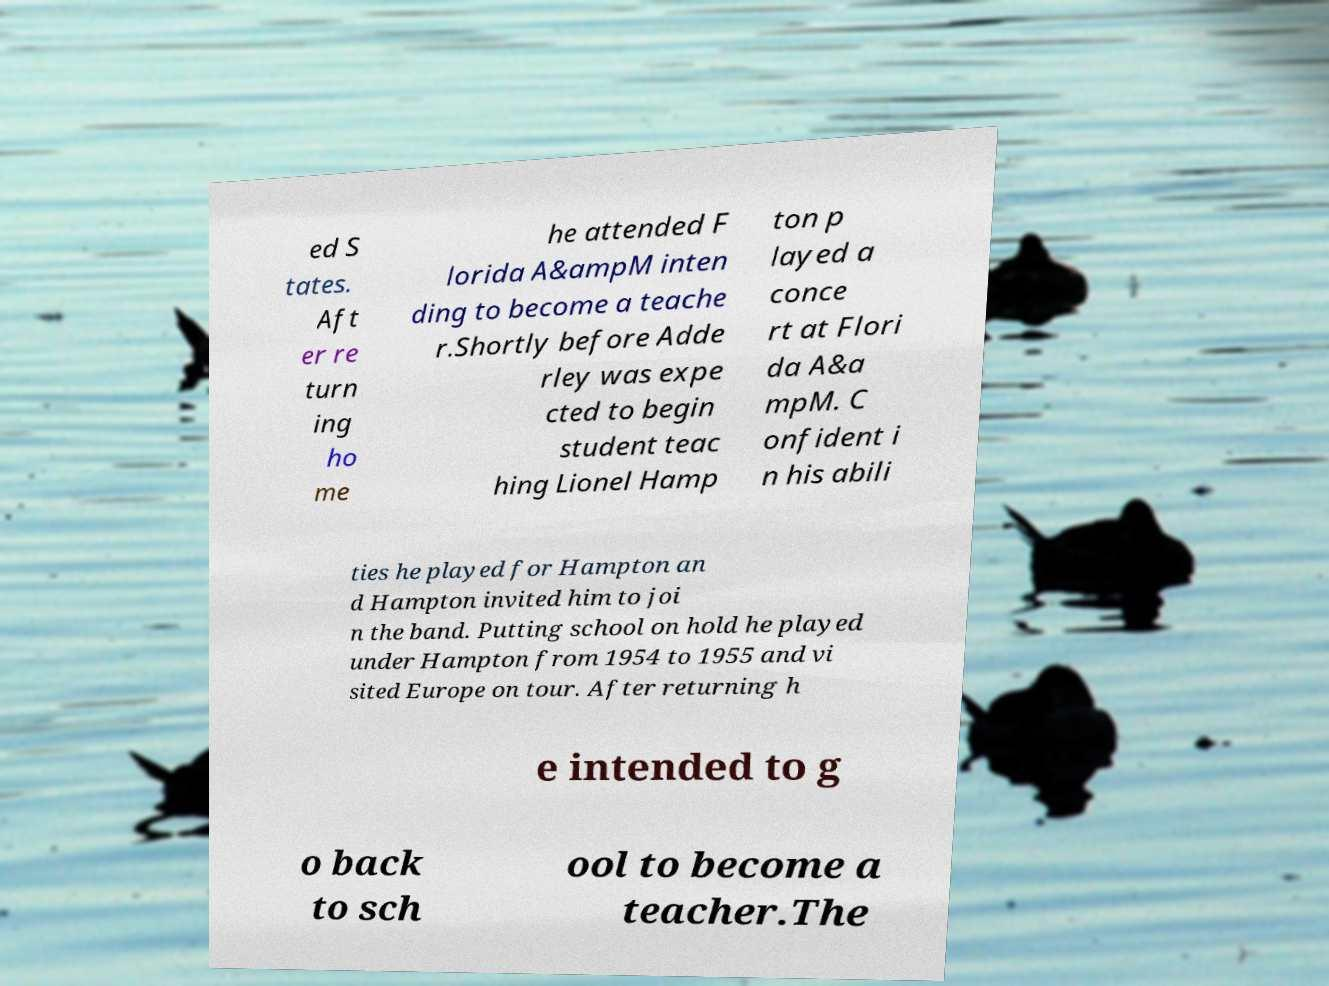Please identify and transcribe the text found in this image. ed S tates. Aft er re turn ing ho me he attended F lorida A&ampM inten ding to become a teache r.Shortly before Adde rley was expe cted to begin student teac hing Lionel Hamp ton p layed a conce rt at Flori da A&a mpM. C onfident i n his abili ties he played for Hampton an d Hampton invited him to joi n the band. Putting school on hold he played under Hampton from 1954 to 1955 and vi sited Europe on tour. After returning h e intended to g o back to sch ool to become a teacher.The 